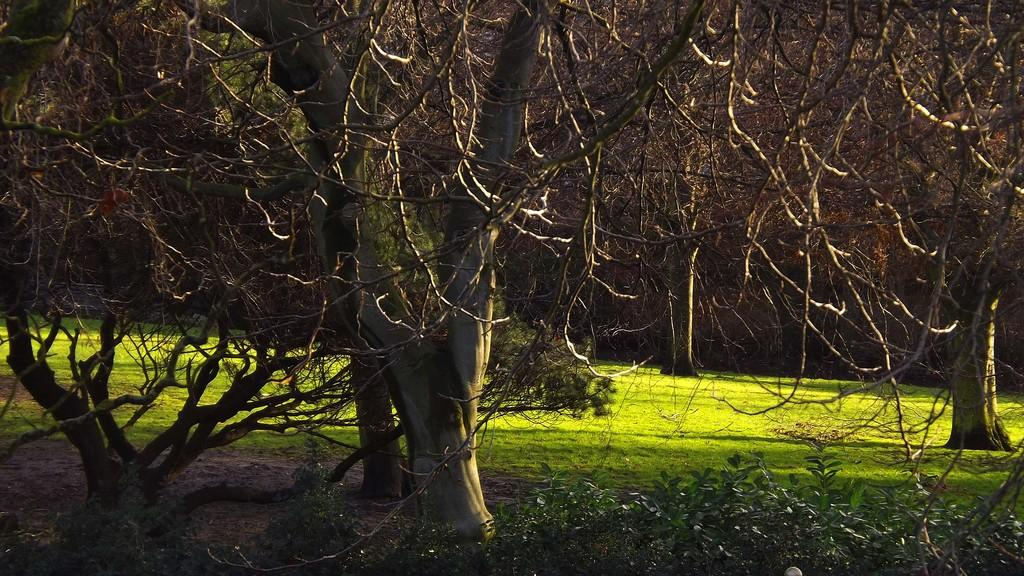What type of vegetation is visible in the image? There is grass, plants, and trees visible in the image. Can you describe the background of the image? The background of the image is dark. How many nerves can be seen in the image? There are no nerves visible in the image; it features vegetation and a dark background. What time of day is it in the image, based on the hour? The provided facts do not mention the time of day or any specific hour, so it cannot be determined from the image. 